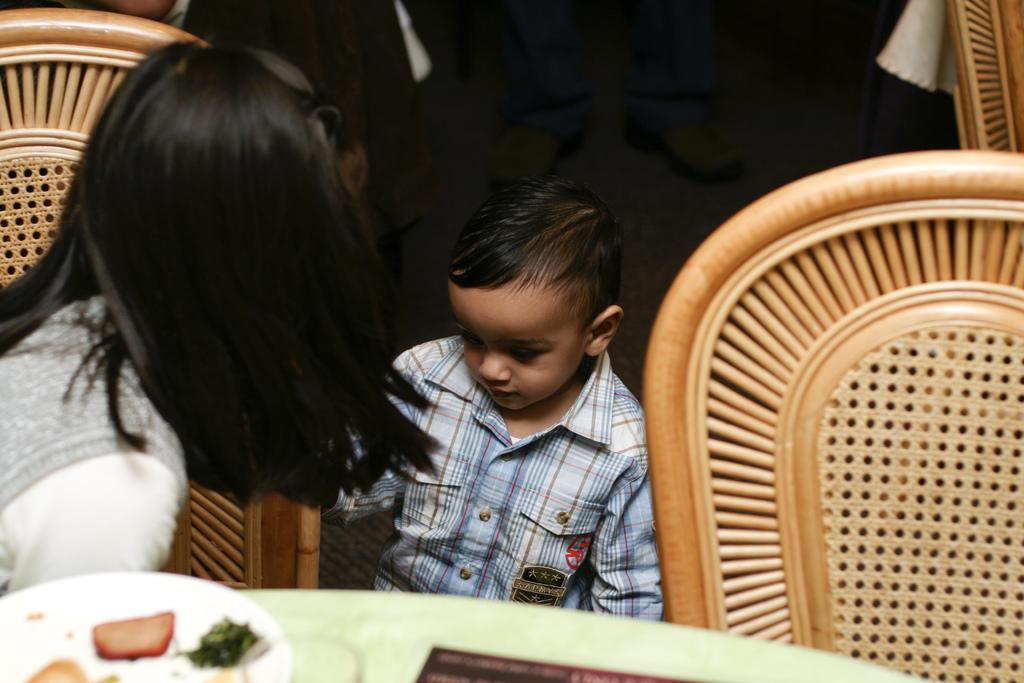Please provide a concise description of this image. In this picture we can see a woman seated on the chair and besides to her we can see a boy, in front of them we can see food items on the table. 